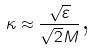Convert formula to latex. <formula><loc_0><loc_0><loc_500><loc_500>\kappa \approx \frac { \sqrt { \varepsilon } } { \sqrt { 2 } M } \text {,}</formula> 